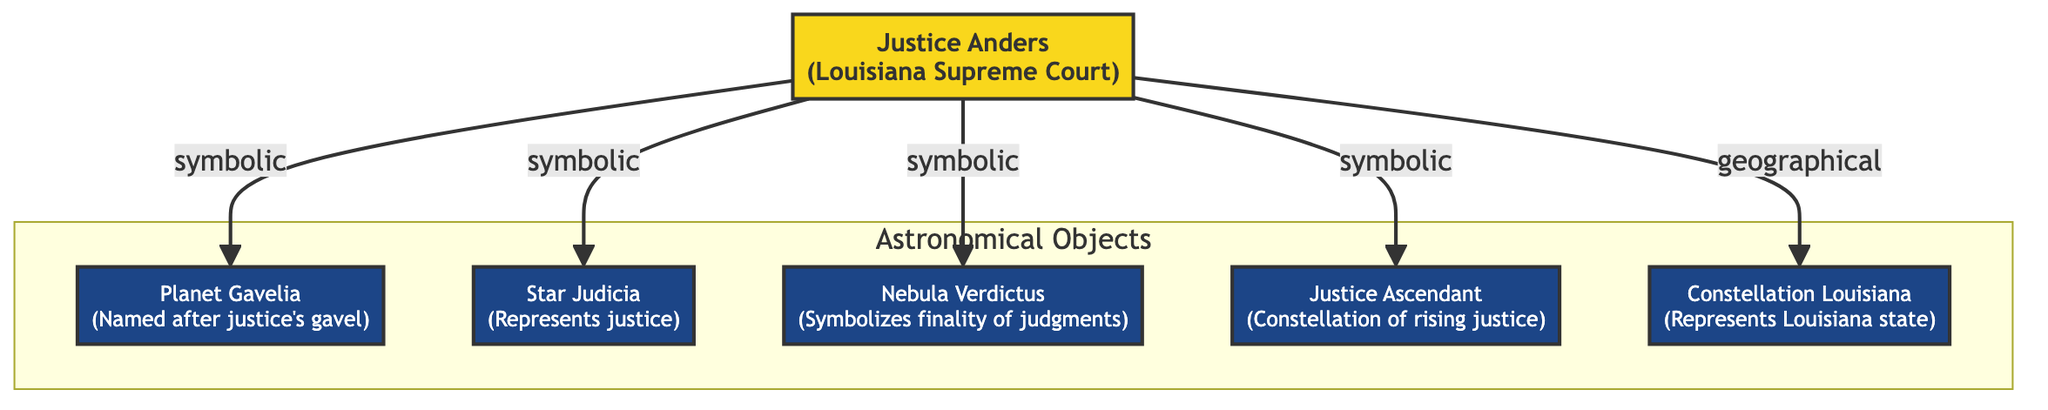What is the name of the justice associated with the diagram? The diagram identifies Justice Anders as the node representing the Louisiana Supreme Court Justice.
Answer: Justice Anders How many astronomical objects are connected to Justice Anders? By analyzing the connections stemming from Justice Anders, we see that there are five distinct astronomical objects linked to this justice.
Answer: 5 What is the name of the nebula depicted in this diagram? The nebula shown in the diagram is labeled as Nebula Verdictus, which symbolizes the finality of judgments.
Answer: Nebula Verdictus Which astronomical object represents justice? The diagram indicates that Star Judicia represents justice, as per the labeling of the corresponding node.
Answer: Star Judicia What does the Constellation Louisiana symbolize in this context? According to the diagram, Constellation Louisiana represents the state of Louisiana, providing a geographical context to the justice theme.
Answer: Louisiana state What is the symbolic connection between Justice Anders and Planet Gavelia? The diagram shows a direct connection labeled "symbolic" from Justice Anders to Planet Gavelia, suggesting that the planet is a representation of the justice's gavel.
Answer: symbolic connection What type of relationship connects Justice Anders to the Constellation Louisiana? The relationship described in the diagram between Justice Anders and Constellation Louisiana is labeled as "geographical," indicating a spatial or locational connection.
Answer: geographical Which object symbolizes the finality of judgments? Within the diagram, the object that symbolizes the finality of judgments is Nebula Verdictus, clearly indicated in its description.
Answer: Nebula Verdictus How many edges are shown in the diagram? Upon inspecting the connections from Justice Anders, there are five edges extending to different astronomical objects, each denoting a relationship with Justice Anders.
Answer: 5 